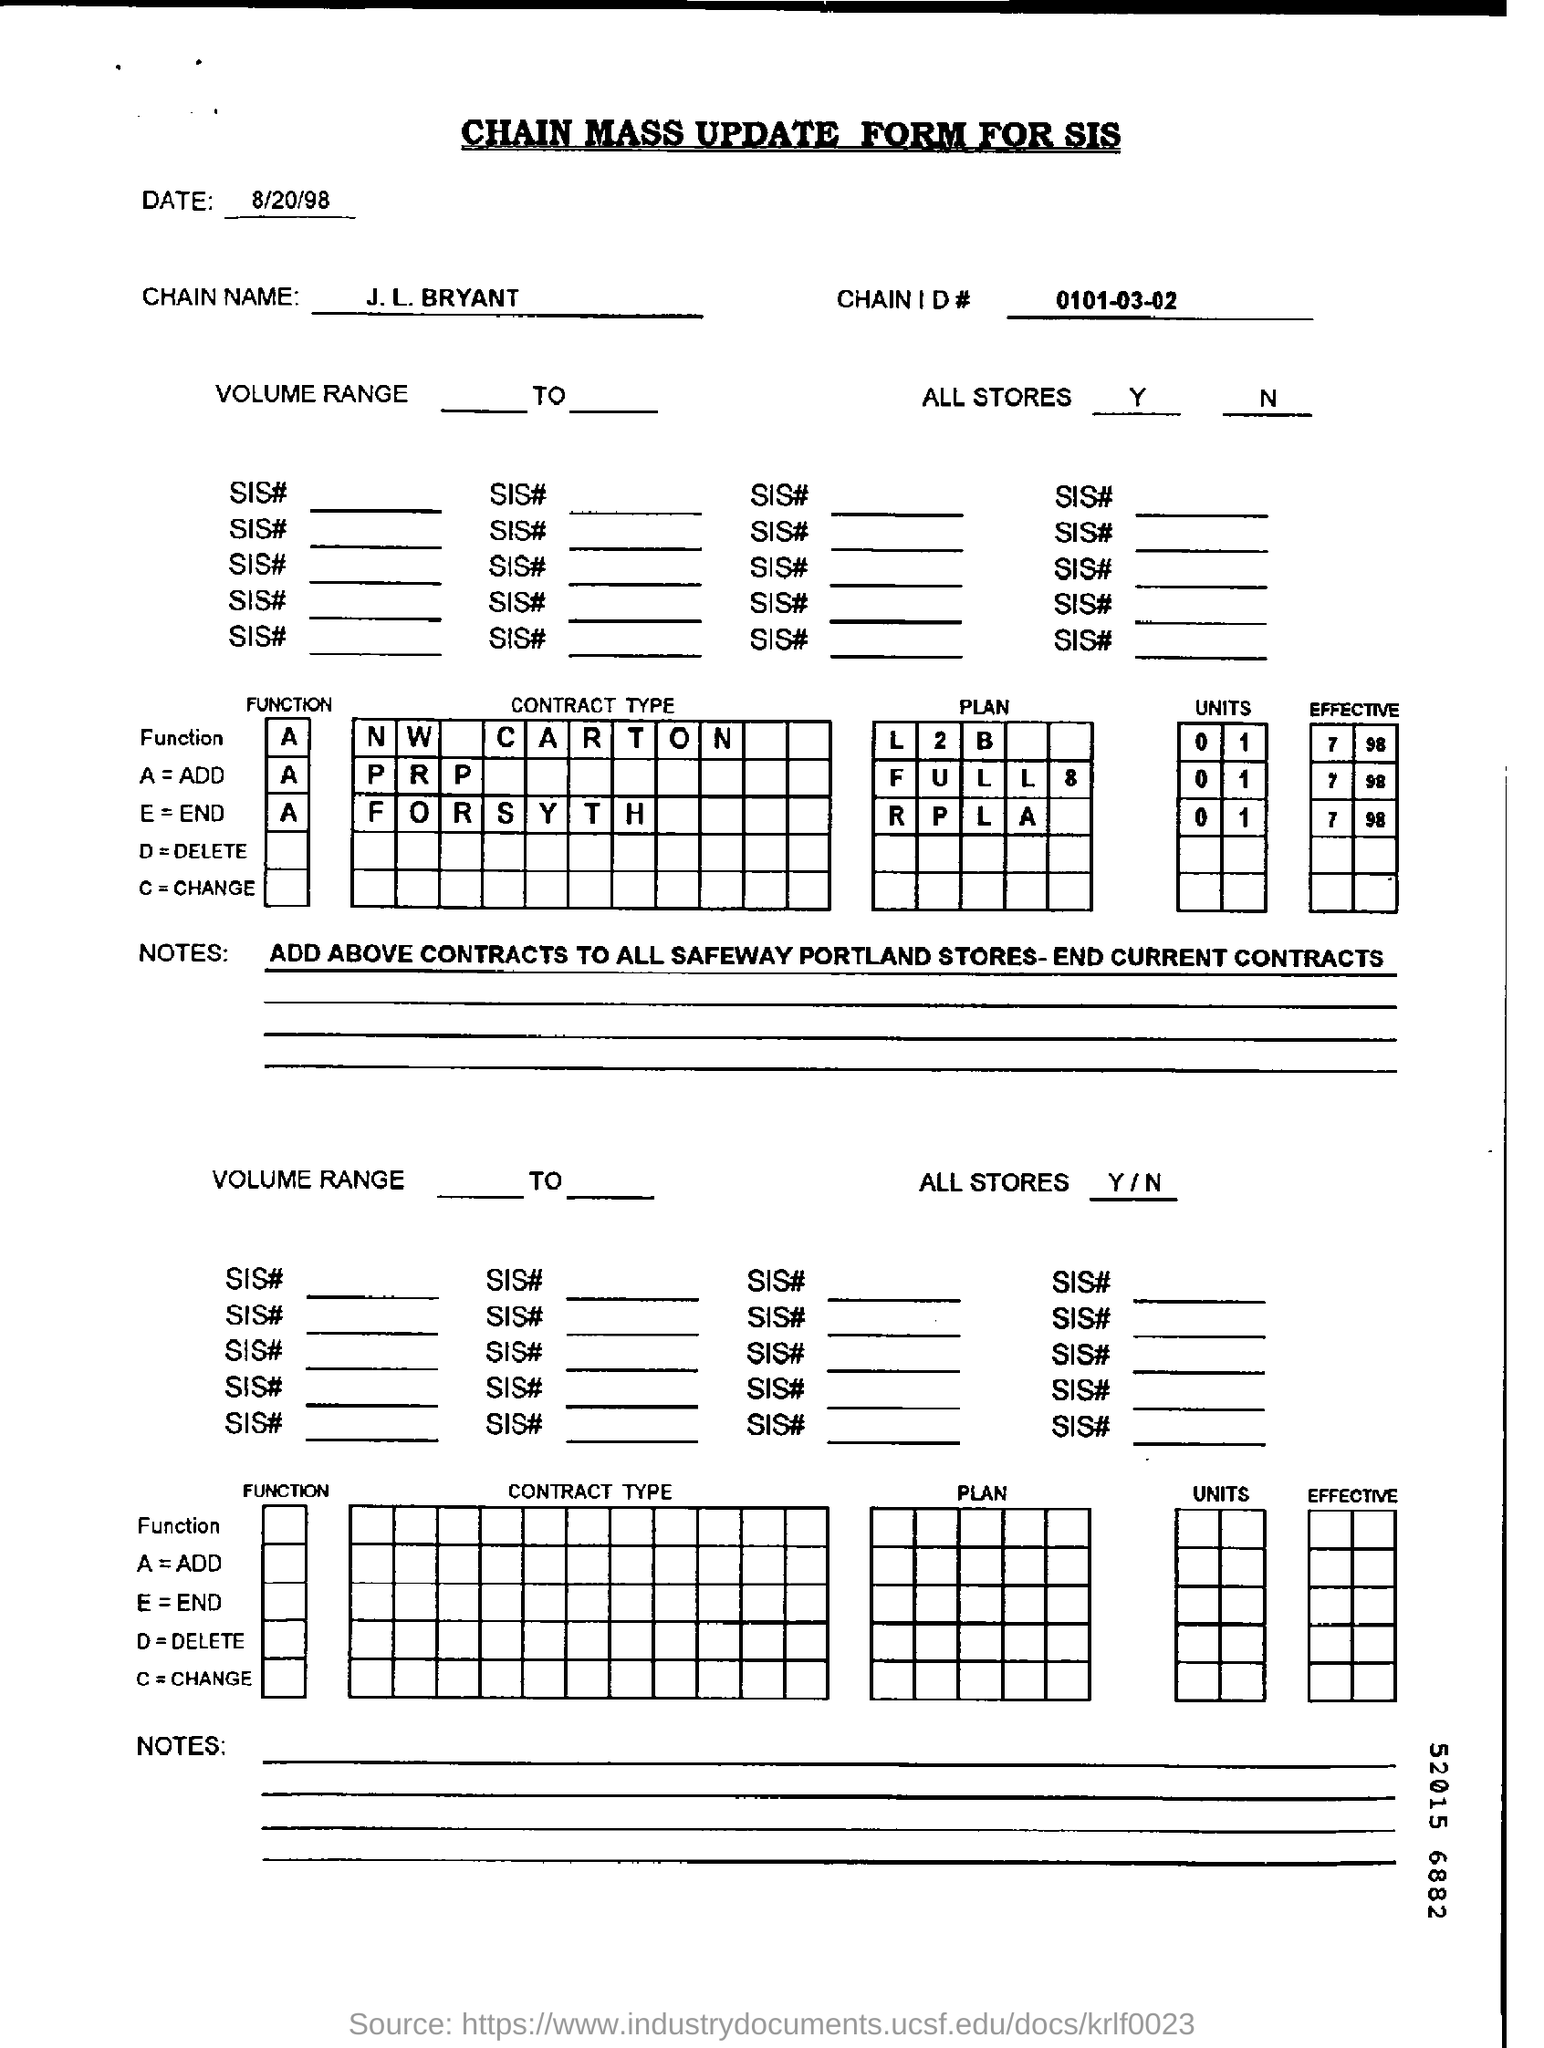Draw attention to some important aspects in this diagram. The document at the top contains the chain mass update form for SIS. The chain name is "J. L. BRYANT..". The date mentioned at the top of the document is August 20, 1998. 